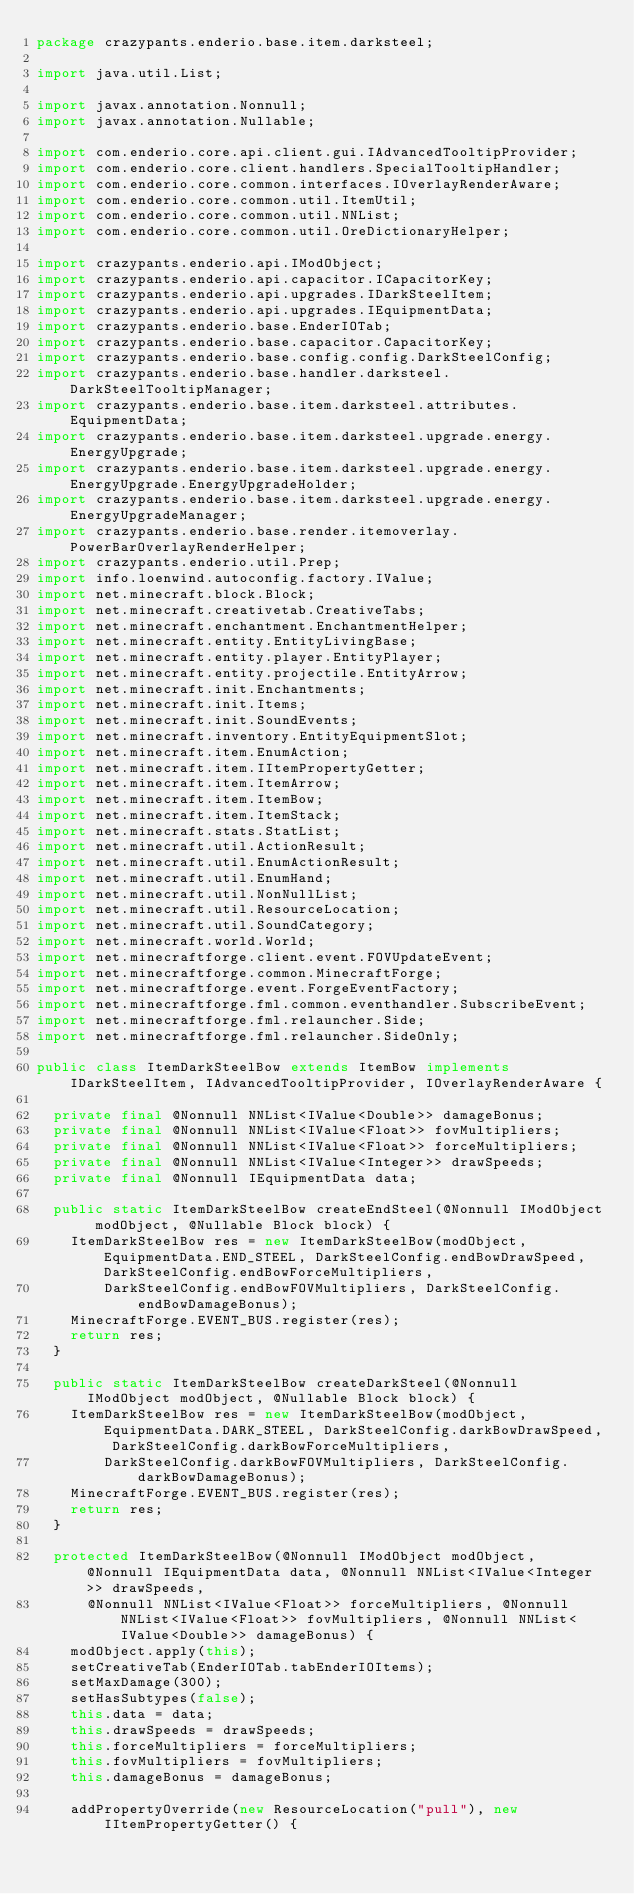<code> <loc_0><loc_0><loc_500><loc_500><_Java_>package crazypants.enderio.base.item.darksteel;

import java.util.List;

import javax.annotation.Nonnull;
import javax.annotation.Nullable;

import com.enderio.core.api.client.gui.IAdvancedTooltipProvider;
import com.enderio.core.client.handlers.SpecialTooltipHandler;
import com.enderio.core.common.interfaces.IOverlayRenderAware;
import com.enderio.core.common.util.ItemUtil;
import com.enderio.core.common.util.NNList;
import com.enderio.core.common.util.OreDictionaryHelper;

import crazypants.enderio.api.IModObject;
import crazypants.enderio.api.capacitor.ICapacitorKey;
import crazypants.enderio.api.upgrades.IDarkSteelItem;
import crazypants.enderio.api.upgrades.IEquipmentData;
import crazypants.enderio.base.EnderIOTab;
import crazypants.enderio.base.capacitor.CapacitorKey;
import crazypants.enderio.base.config.config.DarkSteelConfig;
import crazypants.enderio.base.handler.darksteel.DarkSteelTooltipManager;
import crazypants.enderio.base.item.darksteel.attributes.EquipmentData;
import crazypants.enderio.base.item.darksteel.upgrade.energy.EnergyUpgrade;
import crazypants.enderio.base.item.darksteel.upgrade.energy.EnergyUpgrade.EnergyUpgradeHolder;
import crazypants.enderio.base.item.darksteel.upgrade.energy.EnergyUpgradeManager;
import crazypants.enderio.base.render.itemoverlay.PowerBarOverlayRenderHelper;
import crazypants.enderio.util.Prep;
import info.loenwind.autoconfig.factory.IValue;
import net.minecraft.block.Block;
import net.minecraft.creativetab.CreativeTabs;
import net.minecraft.enchantment.EnchantmentHelper;
import net.minecraft.entity.EntityLivingBase;
import net.minecraft.entity.player.EntityPlayer;
import net.minecraft.entity.projectile.EntityArrow;
import net.minecraft.init.Enchantments;
import net.minecraft.init.Items;
import net.minecraft.init.SoundEvents;
import net.minecraft.inventory.EntityEquipmentSlot;
import net.minecraft.item.EnumAction;
import net.minecraft.item.IItemPropertyGetter;
import net.minecraft.item.ItemArrow;
import net.minecraft.item.ItemBow;
import net.minecraft.item.ItemStack;
import net.minecraft.stats.StatList;
import net.minecraft.util.ActionResult;
import net.minecraft.util.EnumActionResult;
import net.minecraft.util.EnumHand;
import net.minecraft.util.NonNullList;
import net.minecraft.util.ResourceLocation;
import net.minecraft.util.SoundCategory;
import net.minecraft.world.World;
import net.minecraftforge.client.event.FOVUpdateEvent;
import net.minecraftforge.common.MinecraftForge;
import net.minecraftforge.event.ForgeEventFactory;
import net.minecraftforge.fml.common.eventhandler.SubscribeEvent;
import net.minecraftforge.fml.relauncher.Side;
import net.minecraftforge.fml.relauncher.SideOnly;

public class ItemDarkSteelBow extends ItemBow implements IDarkSteelItem, IAdvancedTooltipProvider, IOverlayRenderAware {

  private final @Nonnull NNList<IValue<Double>> damageBonus;
  private final @Nonnull NNList<IValue<Float>> fovMultipliers;
  private final @Nonnull NNList<IValue<Float>> forceMultipliers;
  private final @Nonnull NNList<IValue<Integer>> drawSpeeds;
  private final @Nonnull IEquipmentData data;

  public static ItemDarkSteelBow createEndSteel(@Nonnull IModObject modObject, @Nullable Block block) {
    ItemDarkSteelBow res = new ItemDarkSteelBow(modObject, EquipmentData.END_STEEL, DarkSteelConfig.endBowDrawSpeed, DarkSteelConfig.endBowForceMultipliers,
        DarkSteelConfig.endBowFOVMultipliers, DarkSteelConfig.endBowDamageBonus);
    MinecraftForge.EVENT_BUS.register(res);
    return res;
  }

  public static ItemDarkSteelBow createDarkSteel(@Nonnull IModObject modObject, @Nullable Block block) {
    ItemDarkSteelBow res = new ItemDarkSteelBow(modObject, EquipmentData.DARK_STEEL, DarkSteelConfig.darkBowDrawSpeed, DarkSteelConfig.darkBowForceMultipliers,
        DarkSteelConfig.darkBowFOVMultipliers, DarkSteelConfig.darkBowDamageBonus);
    MinecraftForge.EVENT_BUS.register(res);
    return res;
  }

  protected ItemDarkSteelBow(@Nonnull IModObject modObject, @Nonnull IEquipmentData data, @Nonnull NNList<IValue<Integer>> drawSpeeds,
      @Nonnull NNList<IValue<Float>> forceMultipliers, @Nonnull NNList<IValue<Float>> fovMultipliers, @Nonnull NNList<IValue<Double>> damageBonus) {
    modObject.apply(this);
    setCreativeTab(EnderIOTab.tabEnderIOItems);
    setMaxDamage(300);
    setHasSubtypes(false);
    this.data = data;
    this.drawSpeeds = drawSpeeds;
    this.forceMultipliers = forceMultipliers;
    this.fovMultipliers = fovMultipliers;
    this.damageBonus = damageBonus;

    addPropertyOverride(new ResourceLocation("pull"), new IItemPropertyGetter() {</code> 